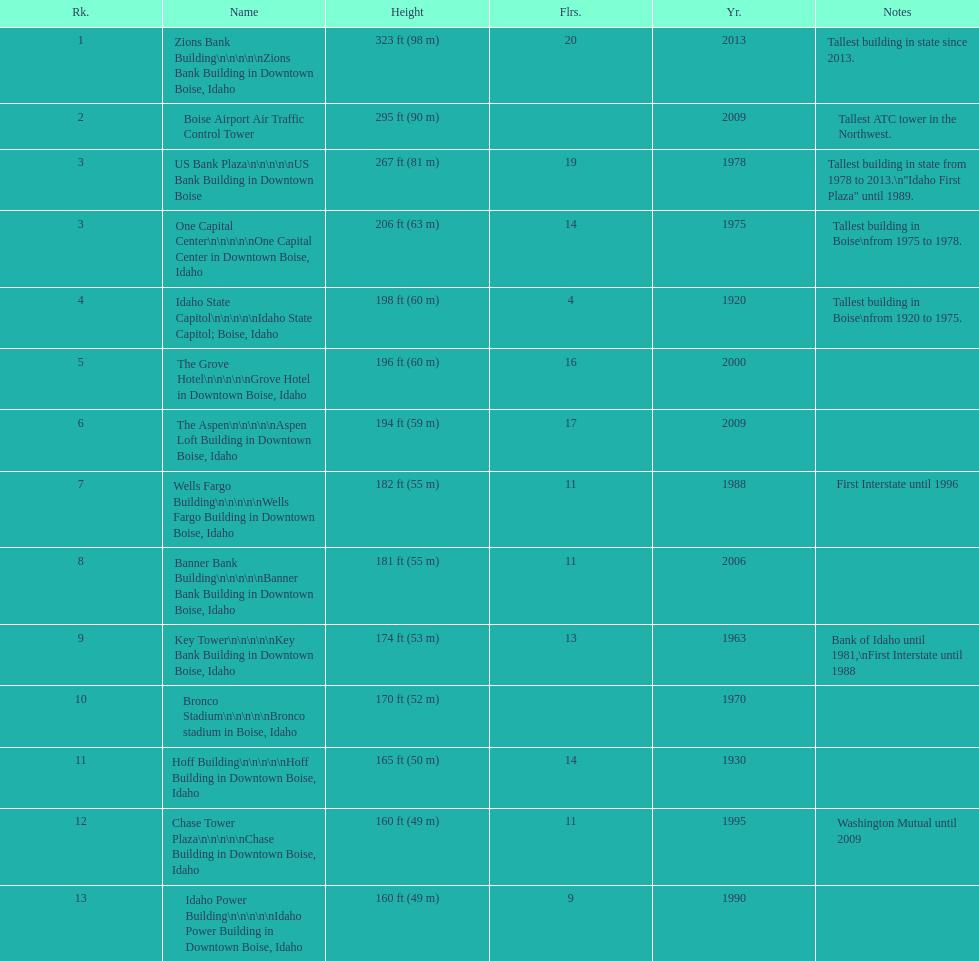Is the bronco stadium above or below 150 ft? Above. 